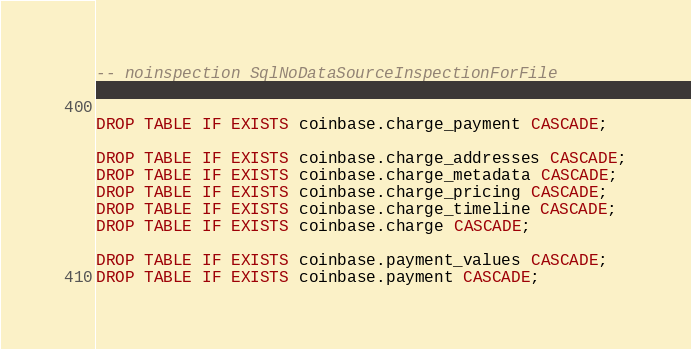Convert code to text. <code><loc_0><loc_0><loc_500><loc_500><_SQL_>-- noinspection SqlNoDataSourceInspectionForFile


DROP TABLE IF EXISTS coinbase.charge_payment CASCADE;

DROP TABLE IF EXISTS coinbase.charge_addresses CASCADE;
DROP TABLE IF EXISTS coinbase.charge_metadata CASCADE;
DROP TABLE IF EXISTS coinbase.charge_pricing CASCADE;
DROP TABLE IF EXISTS coinbase.charge_timeline CASCADE;
DROP TABLE IF EXISTS coinbase.charge CASCADE;

DROP TABLE IF EXISTS coinbase.payment_values CASCADE;
DROP TABLE IF EXISTS coinbase.payment CASCADE;
</code> 